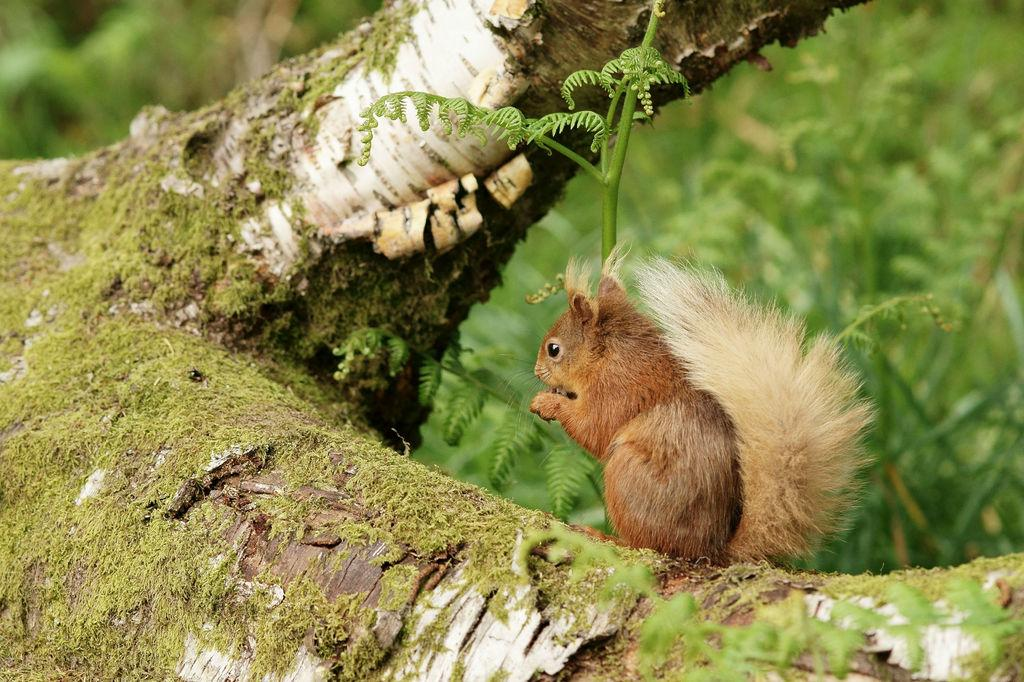What animal is present in the image? There is a squirrel in the image. Where is the squirrel located? The squirrel is on a trunk. Which direction is the squirrel facing? The squirrel is facing towards the left side. What can be seen in the background of the image? There are plants in the background of the image. What type of finger can be seen holding the squirrel in the image? There is no finger holding the squirrel in the image; the squirrel is on a trunk. Is the queen present in the image? There is no queen present in the image; it features a squirrel on a trunk with plants in the background. 